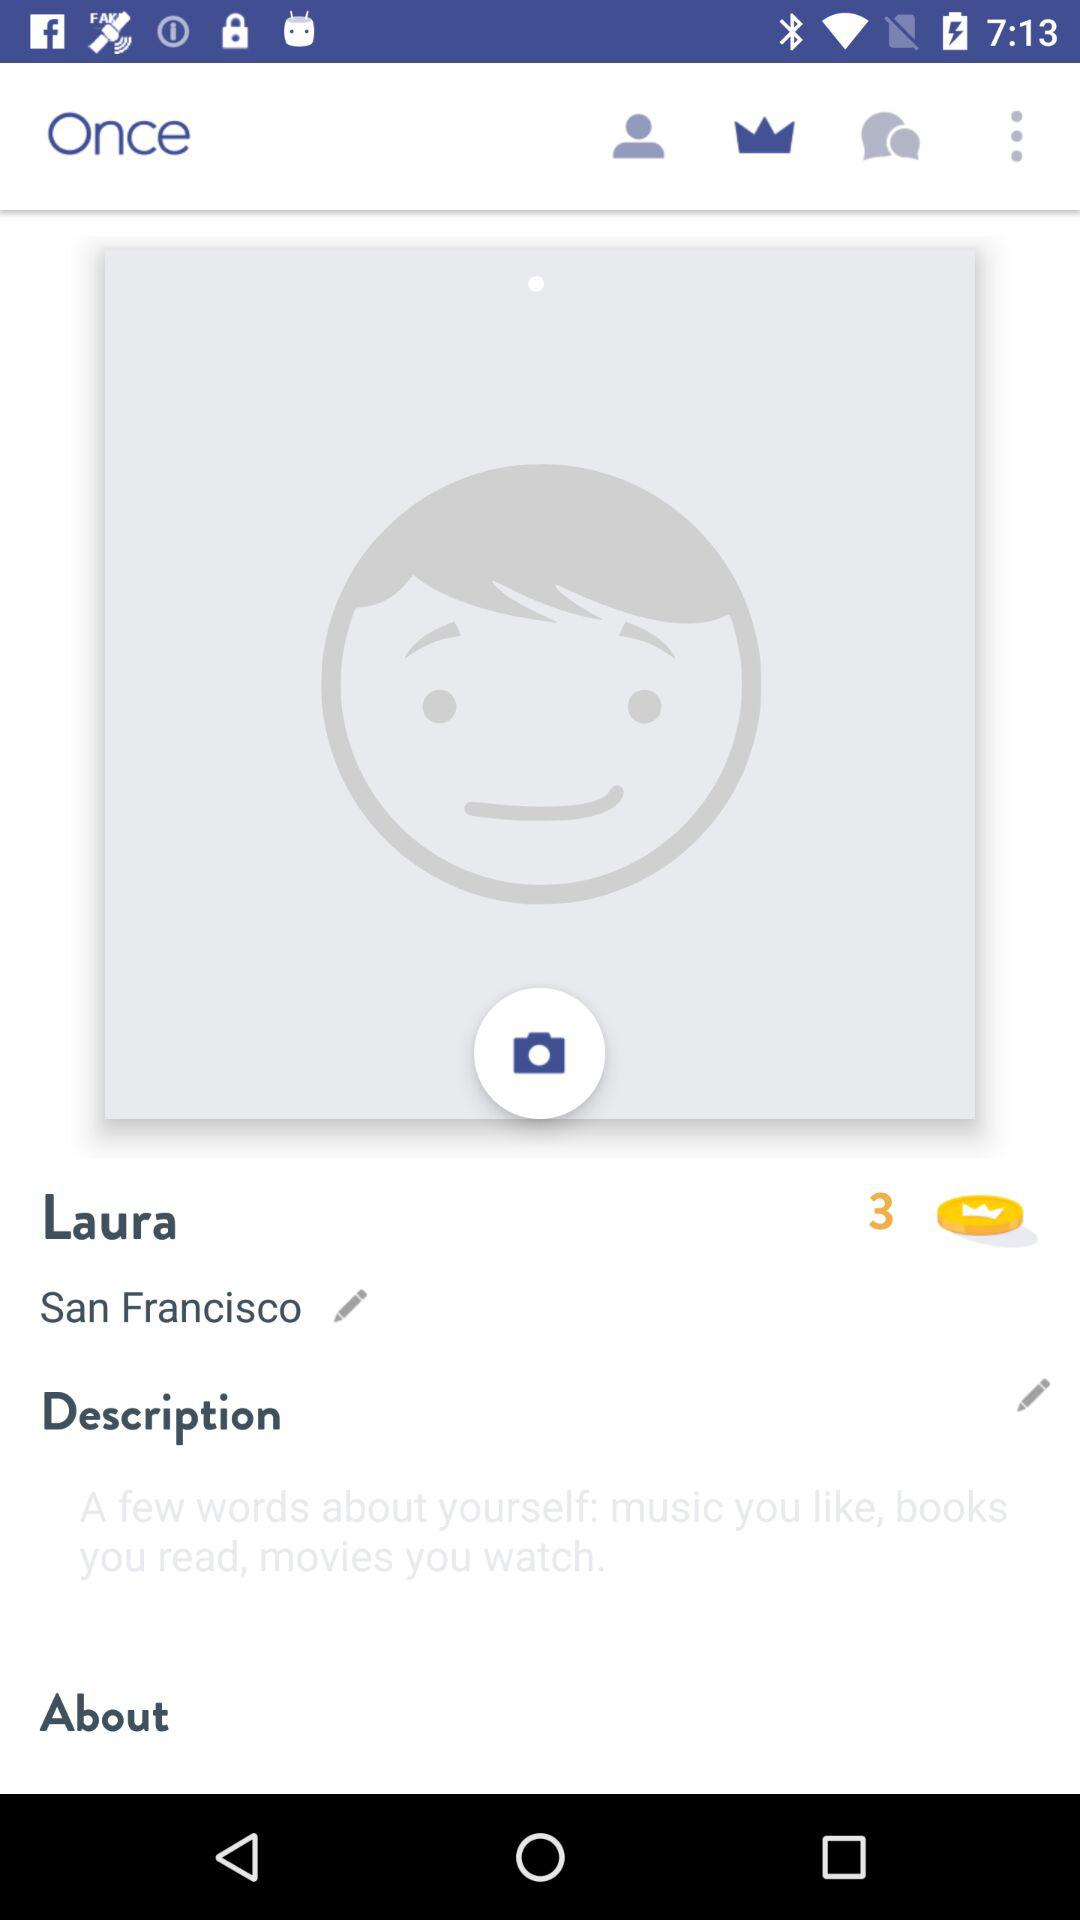What is the name of the person? The name of the person is Laura. 